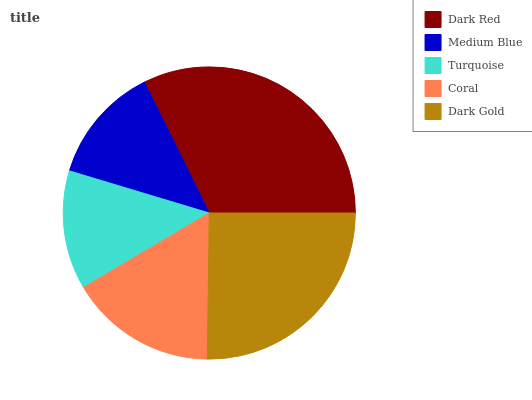Is Medium Blue the minimum?
Answer yes or no. Yes. Is Dark Red the maximum?
Answer yes or no. Yes. Is Turquoise the minimum?
Answer yes or no. No. Is Turquoise the maximum?
Answer yes or no. No. Is Turquoise greater than Medium Blue?
Answer yes or no. Yes. Is Medium Blue less than Turquoise?
Answer yes or no. Yes. Is Medium Blue greater than Turquoise?
Answer yes or no. No. Is Turquoise less than Medium Blue?
Answer yes or no. No. Is Coral the high median?
Answer yes or no. Yes. Is Coral the low median?
Answer yes or no. Yes. Is Dark Gold the high median?
Answer yes or no. No. Is Dark Red the low median?
Answer yes or no. No. 